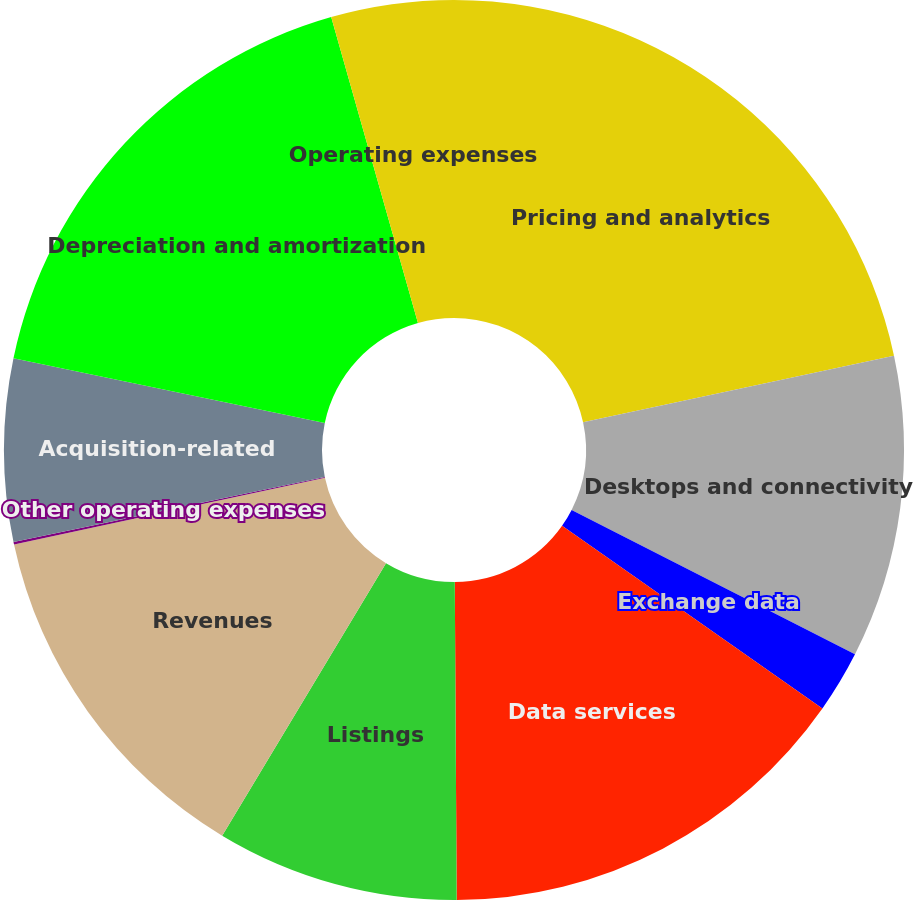Convert chart. <chart><loc_0><loc_0><loc_500><loc_500><pie_chart><fcel>Pricing and analytics<fcel>Desktops and connectivity<fcel>Exchange data<fcel>Data services<fcel>Listings<fcel>Revenues<fcel>Other operating expenses<fcel>Acquisition-related<fcel>Depreciation and amortization<fcel>Operating expenses<nl><fcel>21.64%<fcel>10.86%<fcel>2.24%<fcel>15.17%<fcel>8.71%<fcel>13.02%<fcel>0.09%<fcel>6.55%<fcel>17.33%<fcel>4.4%<nl></chart> 